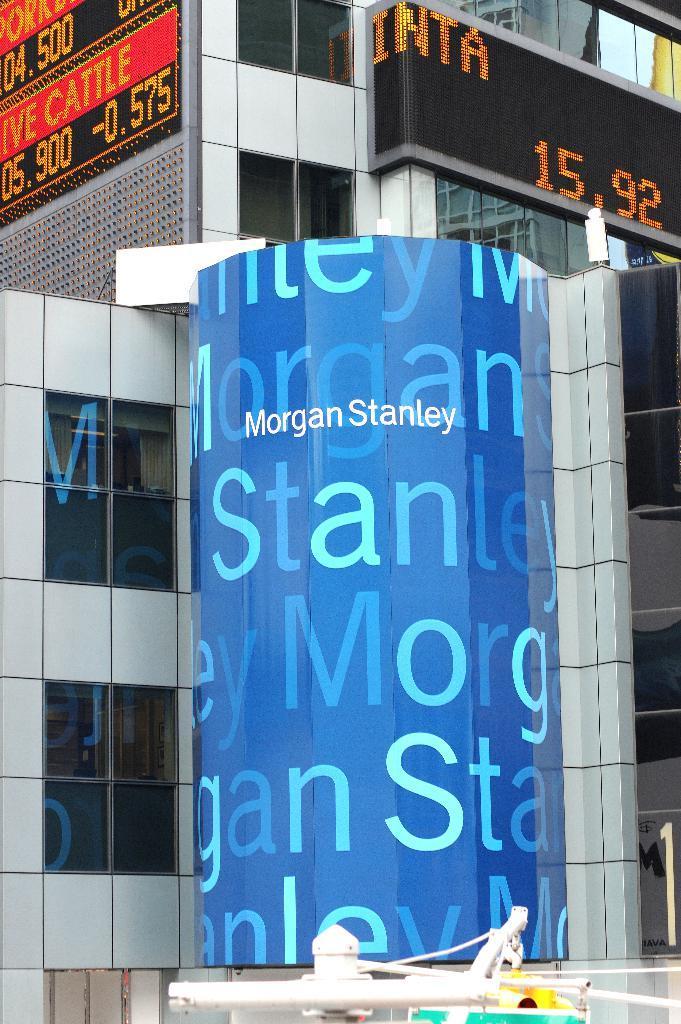Describe this image in one or two sentences. In this picture I can see a board, there are LED screens and there is a building with glass windows. 